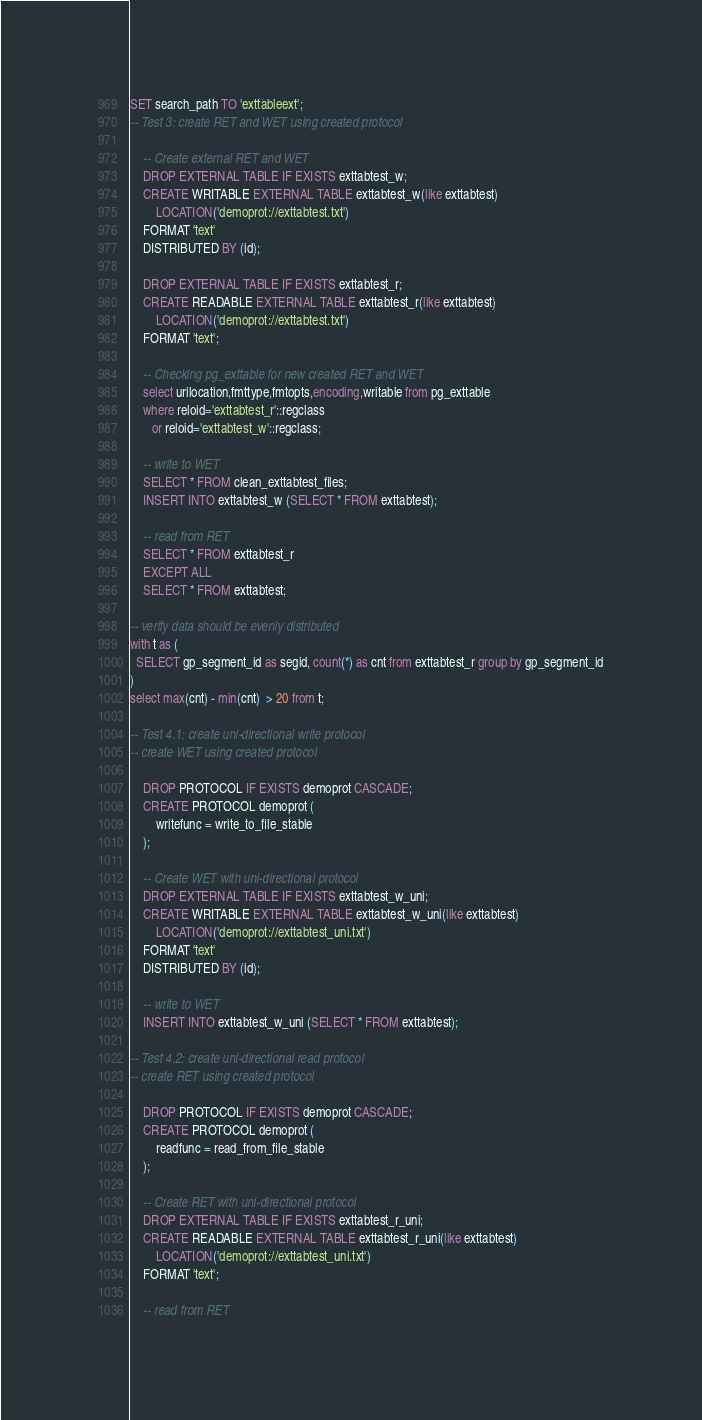<code> <loc_0><loc_0><loc_500><loc_500><_SQL_>SET search_path TO 'exttableext';
-- Test 3: create RET and WET using created protocol

    -- Create external RET and WET
    DROP EXTERNAL TABLE IF EXISTS exttabtest_w;
    CREATE WRITABLE EXTERNAL TABLE exttabtest_w(like exttabtest)
        LOCATION('demoprot://exttabtest.txt') 
    FORMAT 'text'
    DISTRIBUTED BY (id);

    DROP EXTERNAL TABLE IF EXISTS exttabtest_r;
    CREATE READABLE EXTERNAL TABLE exttabtest_r(like exttabtest)
        LOCATION('demoprot://exttabtest.txt') 
    FORMAT 'text';

    -- Checking pg_exttable for new created RET and WET
    select urilocation,fmttype,fmtopts,encoding,writable from pg_exttable 
    where reloid='exttabtest_r'::regclass 
       or reloid='exttabtest_w'::regclass;

    -- write to WET
    SELECT * FROM clean_exttabtest_files;
    INSERT INTO exttabtest_w (SELECT * FROM exttabtest);

    -- read from RET
    SELECT * FROM exttabtest_r
    EXCEPT ALL
    SELECT * FROM exttabtest;

-- verify data should be evenly distributed
with t as (
  SELECT gp_segment_id as segid, count(*) as cnt from exttabtest_r group by gp_segment_id
)
select max(cnt) - min(cnt)  > 20 from t;

-- Test 4.1: create uni-directional write protocol
-- create WET using created protocol

    DROP PROTOCOL IF EXISTS demoprot CASCADE;
    CREATE PROTOCOL demoprot (
        writefunc = write_to_file_stable
    );

    -- Create WET with uni-directional protocol
    DROP EXTERNAL TABLE IF EXISTS exttabtest_w_uni;
    CREATE WRITABLE EXTERNAL TABLE exttabtest_w_uni(like exttabtest)
        LOCATION('demoprot://exttabtest_uni.txt') 
    FORMAT 'text'
    DISTRIBUTED BY (id);

    -- write to WET
    INSERT INTO exttabtest_w_uni (SELECT * FROM exttabtest);

-- Test 4.2: create uni-directional read protocol 
-- create RET using created protocol

    DROP PROTOCOL IF EXISTS demoprot CASCADE;
    CREATE PROTOCOL demoprot (
        readfunc = read_from_file_stable
    );

    -- Create RET with uni-directional protocol
    DROP EXTERNAL TABLE IF EXISTS exttabtest_r_uni;
    CREATE READABLE EXTERNAL TABLE exttabtest_r_uni(like exttabtest)
        LOCATION('demoprot://exttabtest_uni.txt') 
    FORMAT 'text';

    -- read from RET</code> 